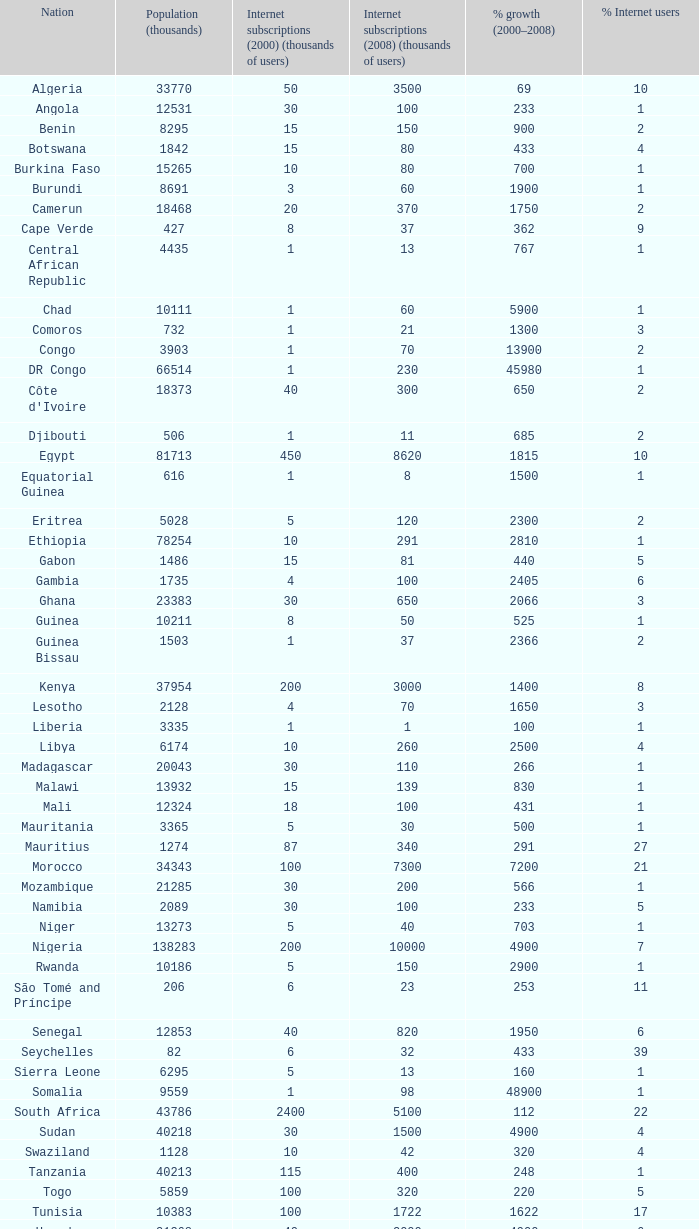Could you parse the entire table as a dict? {'header': ['Nation', 'Population (thousands)', 'Internet subscriptions (2000) (thousands of users)', 'Internet subscriptions (2008) (thousands of users)', '% growth (2000–2008)', '% Internet users'], 'rows': [['Algeria', '33770', '50', '3500', '69', '10'], ['Angola', '12531', '30', '100', '233', '1'], ['Benin', '8295', '15', '150', '900', '2'], ['Botswana', '1842', '15', '80', '433', '4'], ['Burkina Faso', '15265', '10', '80', '700', '1'], ['Burundi', '8691', '3', '60', '1900', '1'], ['Camerun', '18468', '20', '370', '1750', '2'], ['Cape Verde', '427', '8', '37', '362', '9'], ['Central African Republic', '4435', '1', '13', '767', '1'], ['Chad', '10111', '1', '60', '5900', '1'], ['Comoros', '732', '1', '21', '1300', '3'], ['Congo', '3903', '1', '70', '13900', '2'], ['DR Congo', '66514', '1', '230', '45980', '1'], ["Côte d'Ivoire", '18373', '40', '300', '650', '2'], ['Djibouti', '506', '1', '11', '685', '2'], ['Egypt', '81713', '450', '8620', '1815', '10'], ['Equatorial Guinea', '616', '1', '8', '1500', '1'], ['Eritrea', '5028', '5', '120', '2300', '2'], ['Ethiopia', '78254', '10', '291', '2810', '1'], ['Gabon', '1486', '15', '81', '440', '5'], ['Gambia', '1735', '4', '100', '2405', '6'], ['Ghana', '23383', '30', '650', '2066', '3'], ['Guinea', '10211', '8', '50', '525', '1'], ['Guinea Bissau', '1503', '1', '37', '2366', '2'], ['Kenya', '37954', '200', '3000', '1400', '8'], ['Lesotho', '2128', '4', '70', '1650', '3'], ['Liberia', '3335', '1', '1', '100', '1'], ['Libya', '6174', '10', '260', '2500', '4'], ['Madagascar', '20043', '30', '110', '266', '1'], ['Malawi', '13932', '15', '139', '830', '1'], ['Mali', '12324', '18', '100', '431', '1'], ['Mauritania', '3365', '5', '30', '500', '1'], ['Mauritius', '1274', '87', '340', '291', '27'], ['Morocco', '34343', '100', '7300', '7200', '21'], ['Mozambique', '21285', '30', '200', '566', '1'], ['Namibia', '2089', '30', '100', '233', '5'], ['Niger', '13273', '5', '40', '703', '1'], ['Nigeria', '138283', '200', '10000', '4900', '7'], ['Rwanda', '10186', '5', '150', '2900', '1'], ['São Tomé and Príncipe', '206', '6', '23', '253', '11'], ['Senegal', '12853', '40', '820', '1950', '6'], ['Seychelles', '82', '6', '32', '433', '39'], ['Sierra Leone', '6295', '5', '13', '160', '1'], ['Somalia', '9559', '1', '98', '48900', '1'], ['South Africa', '43786', '2400', '5100', '112', '22'], ['Sudan', '40218', '30', '1500', '4900', '4'], ['Swaziland', '1128', '10', '42', '320', '4'], ['Tanzania', '40213', '115', '400', '248', '1'], ['Togo', '5859', '100', '320', '220', '5'], ['Tunisia', '10383', '100', '1722', '1622', '17'], ['Uganda', '31368', '40', '2000', '4900', '6'], ['Zambia', '11669', '20', '500', '2400', '4'], ['Zimbabwe', '12382', '50', '1351', '2602', '11']]} What is the maximum percentage grown 2000-2008 in burundi 1900.0. 